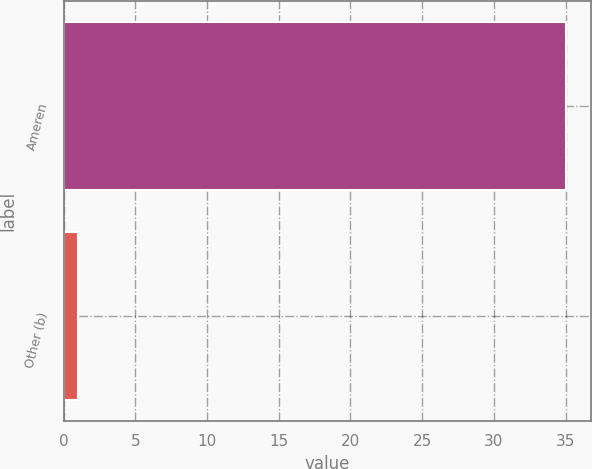<chart> <loc_0><loc_0><loc_500><loc_500><bar_chart><fcel>Ameren<fcel>Other (b)<nl><fcel>35<fcel>1<nl></chart> 